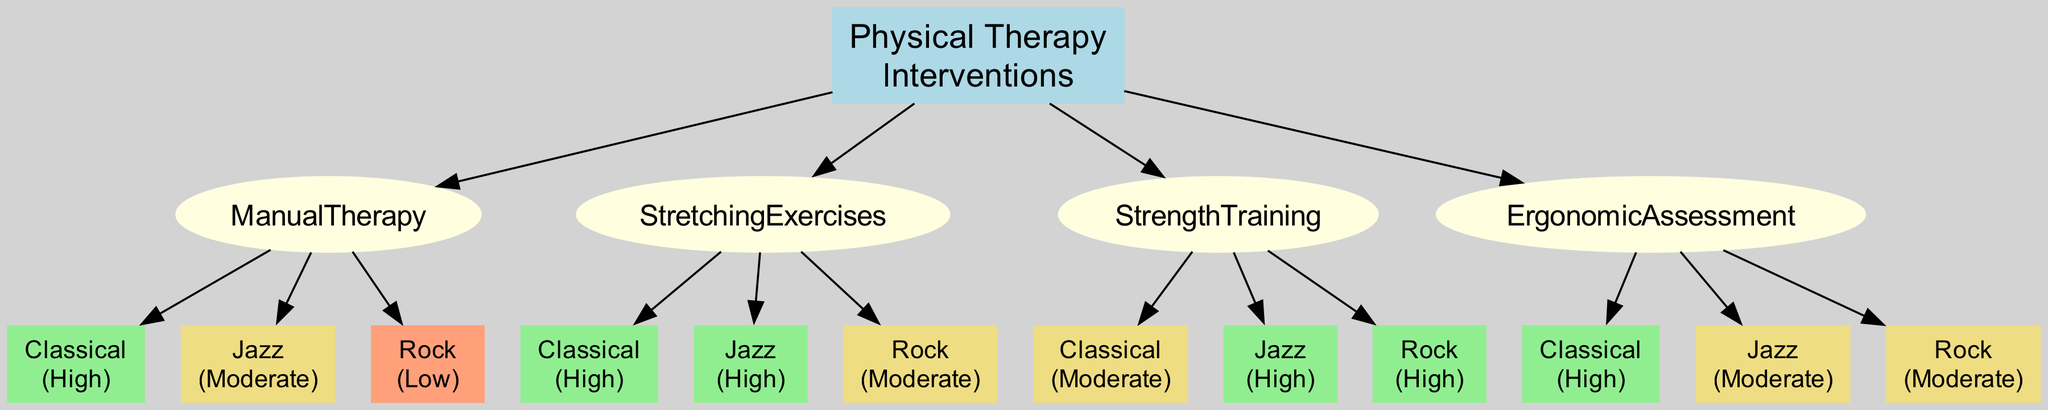What is the effectiveness of Manual Therapy for Classical music? The diagram specifies the effectiveness of Manual Therapy for Classical music as "High". This can be found directly in the branch under Manual Therapy that connects to the Classical node.
Answer: High What intervention shows the lowest effectiveness for Rock music? By examining the effectiveness ratings for Rock music across all interventions, Manual Therapy shows "Low" effectiveness, which is the lowest rating among the interventions listed for Rock music.
Answer: Manual Therapy How many interventions are listed in the diagram? The diagram contains four distinct interventions: Manual Therapy, Stretching Exercises, Strength Training, and Ergonomic Assessment. Counting these nodes will yield the total.
Answer: 4 Which musical genre benefits most from Strength Training according to the diagram? Strength Training has a "High" effectiveness rating specifically for Jazz music, which is the highest rating for that intervention, making Jazz the genre that benefits most from it.
Answer: Jazz Which intervention is highly effective for both Classical and Jazz music? Analyzing the effectiveness ratings, Stretching Exercises shows "High" effectiveness for both Classical and Jazz music. This requires checking both genre effectiveness values under Stretching Exercises.
Answer: Stretching Exercises What is the effectiveness of Ergonomic Assessment for Jazz music? Looking directly at the Ergonomic Assessment node in the diagram, it connects to Jazz with a rating of "Moderate", indicating the level of effectiveness for that genre.
Answer: Moderate Which intervention has the same effectiveness rating for Classical and Ergonomic Assessment? The effectiveness rating for Classical is "High" for both Manual Therapy and Ergonomic Assessment. This requires cross-referencing both interventions' effectiveness regarding Classical music to find the commonality.
Answer: Manual Therapy Which intervention is most effective overall for Classical music? By comparing the ratings of all interventions for Classical music, both Manual Therapy and Stretching Exercises achieve "High", but since they are equal, either can be considered the most effective. Manual Therapy is mentioned first in the hierarchy, which could imply it as a primary choice.
Answer: Manual Therapy What color code represents "Moderate" effectiveness in the diagram? The nodes representing "Moderate" effectiveness are shown in a color that corresponds to "lightgoldenrod". This determination is made by identifying the visual representation associated with that specific effectiveness rating.
Answer: lightgoldenrod 